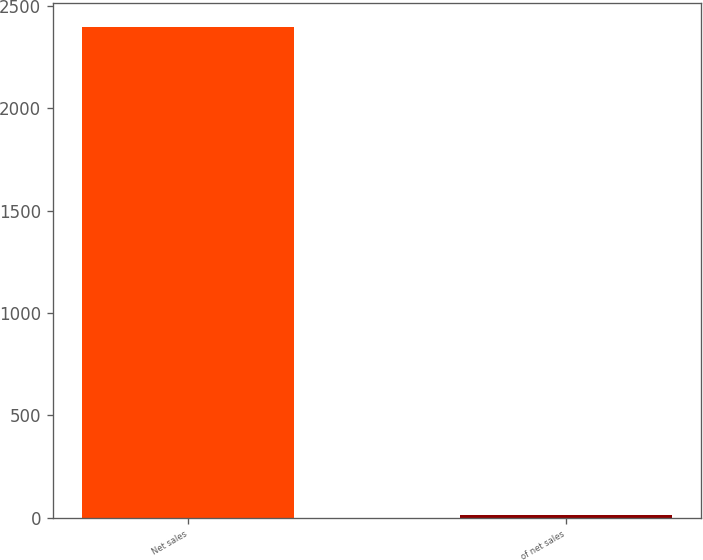<chart> <loc_0><loc_0><loc_500><loc_500><bar_chart><fcel>Net sales<fcel>of net sales<nl><fcel>2394.8<fcel>14.6<nl></chart> 